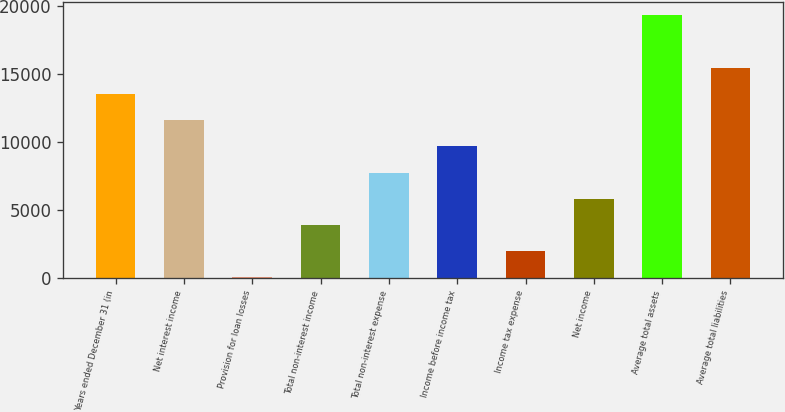Convert chart. <chart><loc_0><loc_0><loc_500><loc_500><bar_chart><fcel>Years ended December 31 (in<fcel>Net interest income<fcel>Provision for loan losses<fcel>Total non-interest income<fcel>Total non-interest expense<fcel>Income before income tax<fcel>Income tax expense<fcel>Net income<fcel>Average total assets<fcel>Average total liabilities<nl><fcel>13551.2<fcel>11622.1<fcel>47.6<fcel>3905.78<fcel>7763.96<fcel>9693.05<fcel>1976.69<fcel>5834.87<fcel>19338.5<fcel>15480.3<nl></chart> 